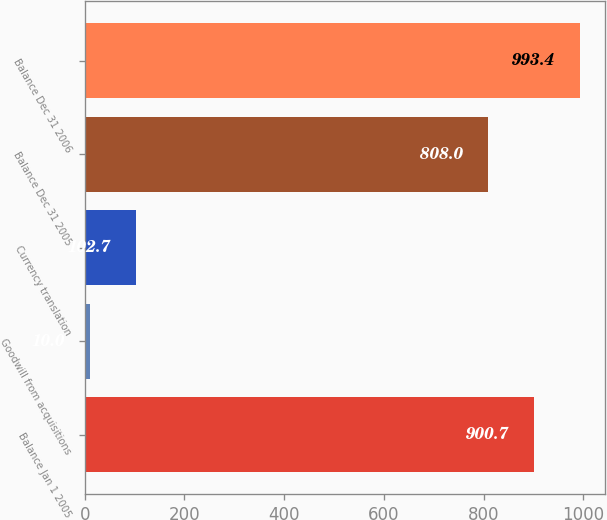Convert chart to OTSL. <chart><loc_0><loc_0><loc_500><loc_500><bar_chart><fcel>Balance Jan 1 2005<fcel>Goodwill from acquisitions<fcel>Currency translation<fcel>Balance Dec 31 2005<fcel>Balance Dec 31 2006<nl><fcel>900.7<fcel>10<fcel>102.7<fcel>808<fcel>993.4<nl></chart> 